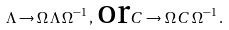<formula> <loc_0><loc_0><loc_500><loc_500>\Lambda \rightarrow \Omega \, \Lambda \, \Omega ^ { - 1 } \, , \, \text {or} C \rightarrow \Omega \, C \, \Omega ^ { - 1 } \, .</formula> 